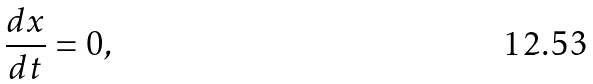Convert formula to latex. <formula><loc_0><loc_0><loc_500><loc_500>\frac { d x } { d t } = 0 ,</formula> 